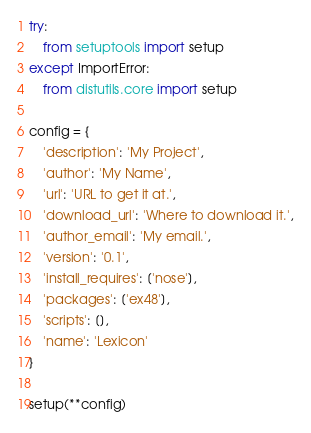Convert code to text. <code><loc_0><loc_0><loc_500><loc_500><_Python_>try:
    from setuptools import setup
except ImportError:
    from distutils.core import setup

config = {
    'description': 'My Project',
    'author': 'My Name',
    'url': 'URL to get it at.',
    'download_url': 'Where to download it.',
    'author_email': 'My email.',
    'version': '0.1',
    'install_requires': ['nose'],
    'packages': ['ex48'],
    'scripts': [],
    'name': 'Lexicon'
}

setup(**config)</code> 